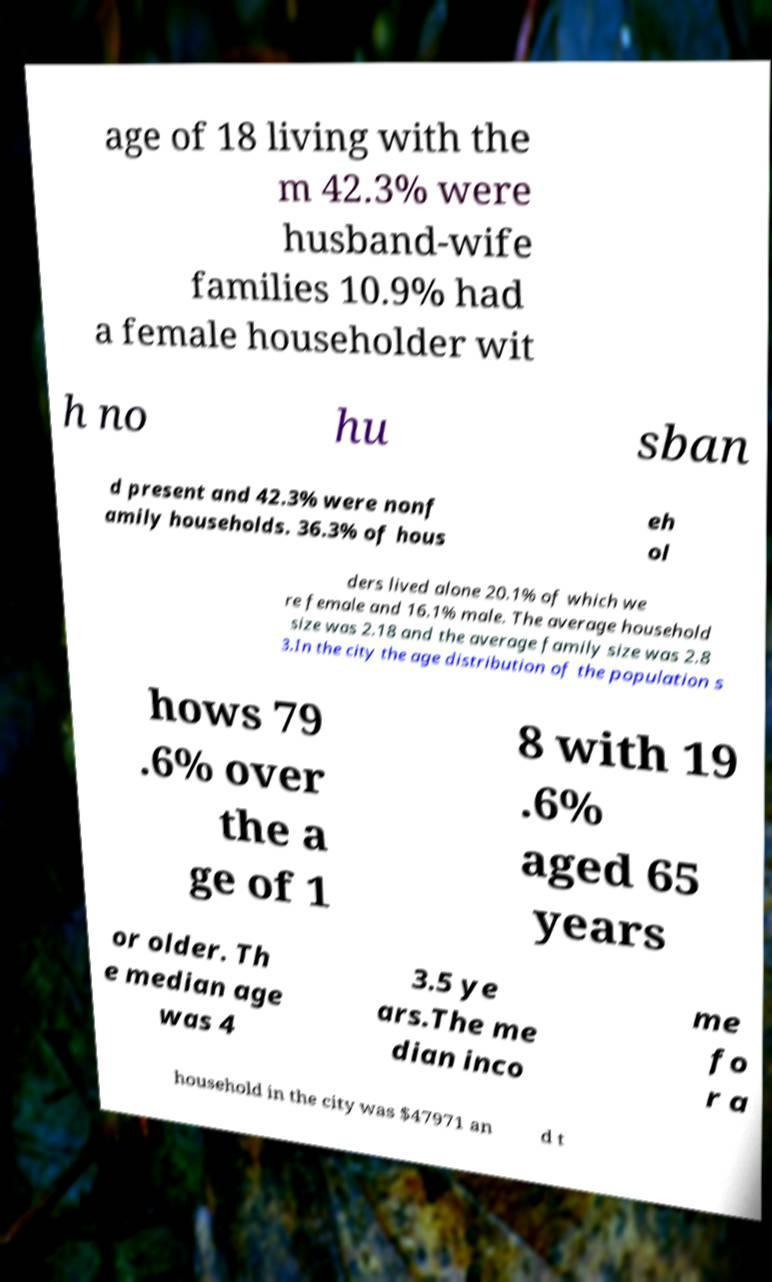There's text embedded in this image that I need extracted. Can you transcribe it verbatim? age of 18 living with the m 42.3% were husband-wife families 10.9% had a female householder wit h no hu sban d present and 42.3% were nonf amily households. 36.3% of hous eh ol ders lived alone 20.1% of which we re female and 16.1% male. The average household size was 2.18 and the average family size was 2.8 3.In the city the age distribution of the population s hows 79 .6% over the a ge of 1 8 with 19 .6% aged 65 years or older. Th e median age was 4 3.5 ye ars.The me dian inco me fo r a household in the city was $47971 an d t 